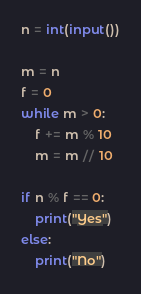<code> <loc_0><loc_0><loc_500><loc_500><_Python_>n = int(input())

m = n
f = 0
while m > 0:
    f += m % 10
    m = m // 10

if n % f == 0:
    print("Yes")
else:
    print("No")
</code> 